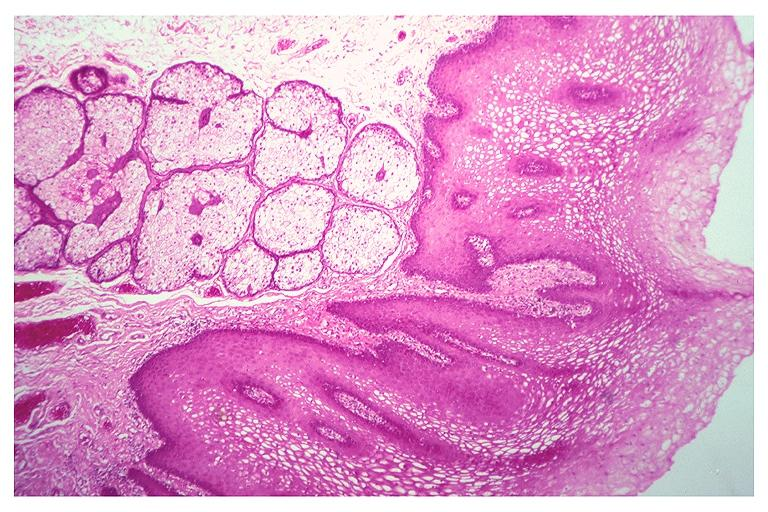s lymphoid atrophy in newborn present?
Answer the question using a single word or phrase. No 